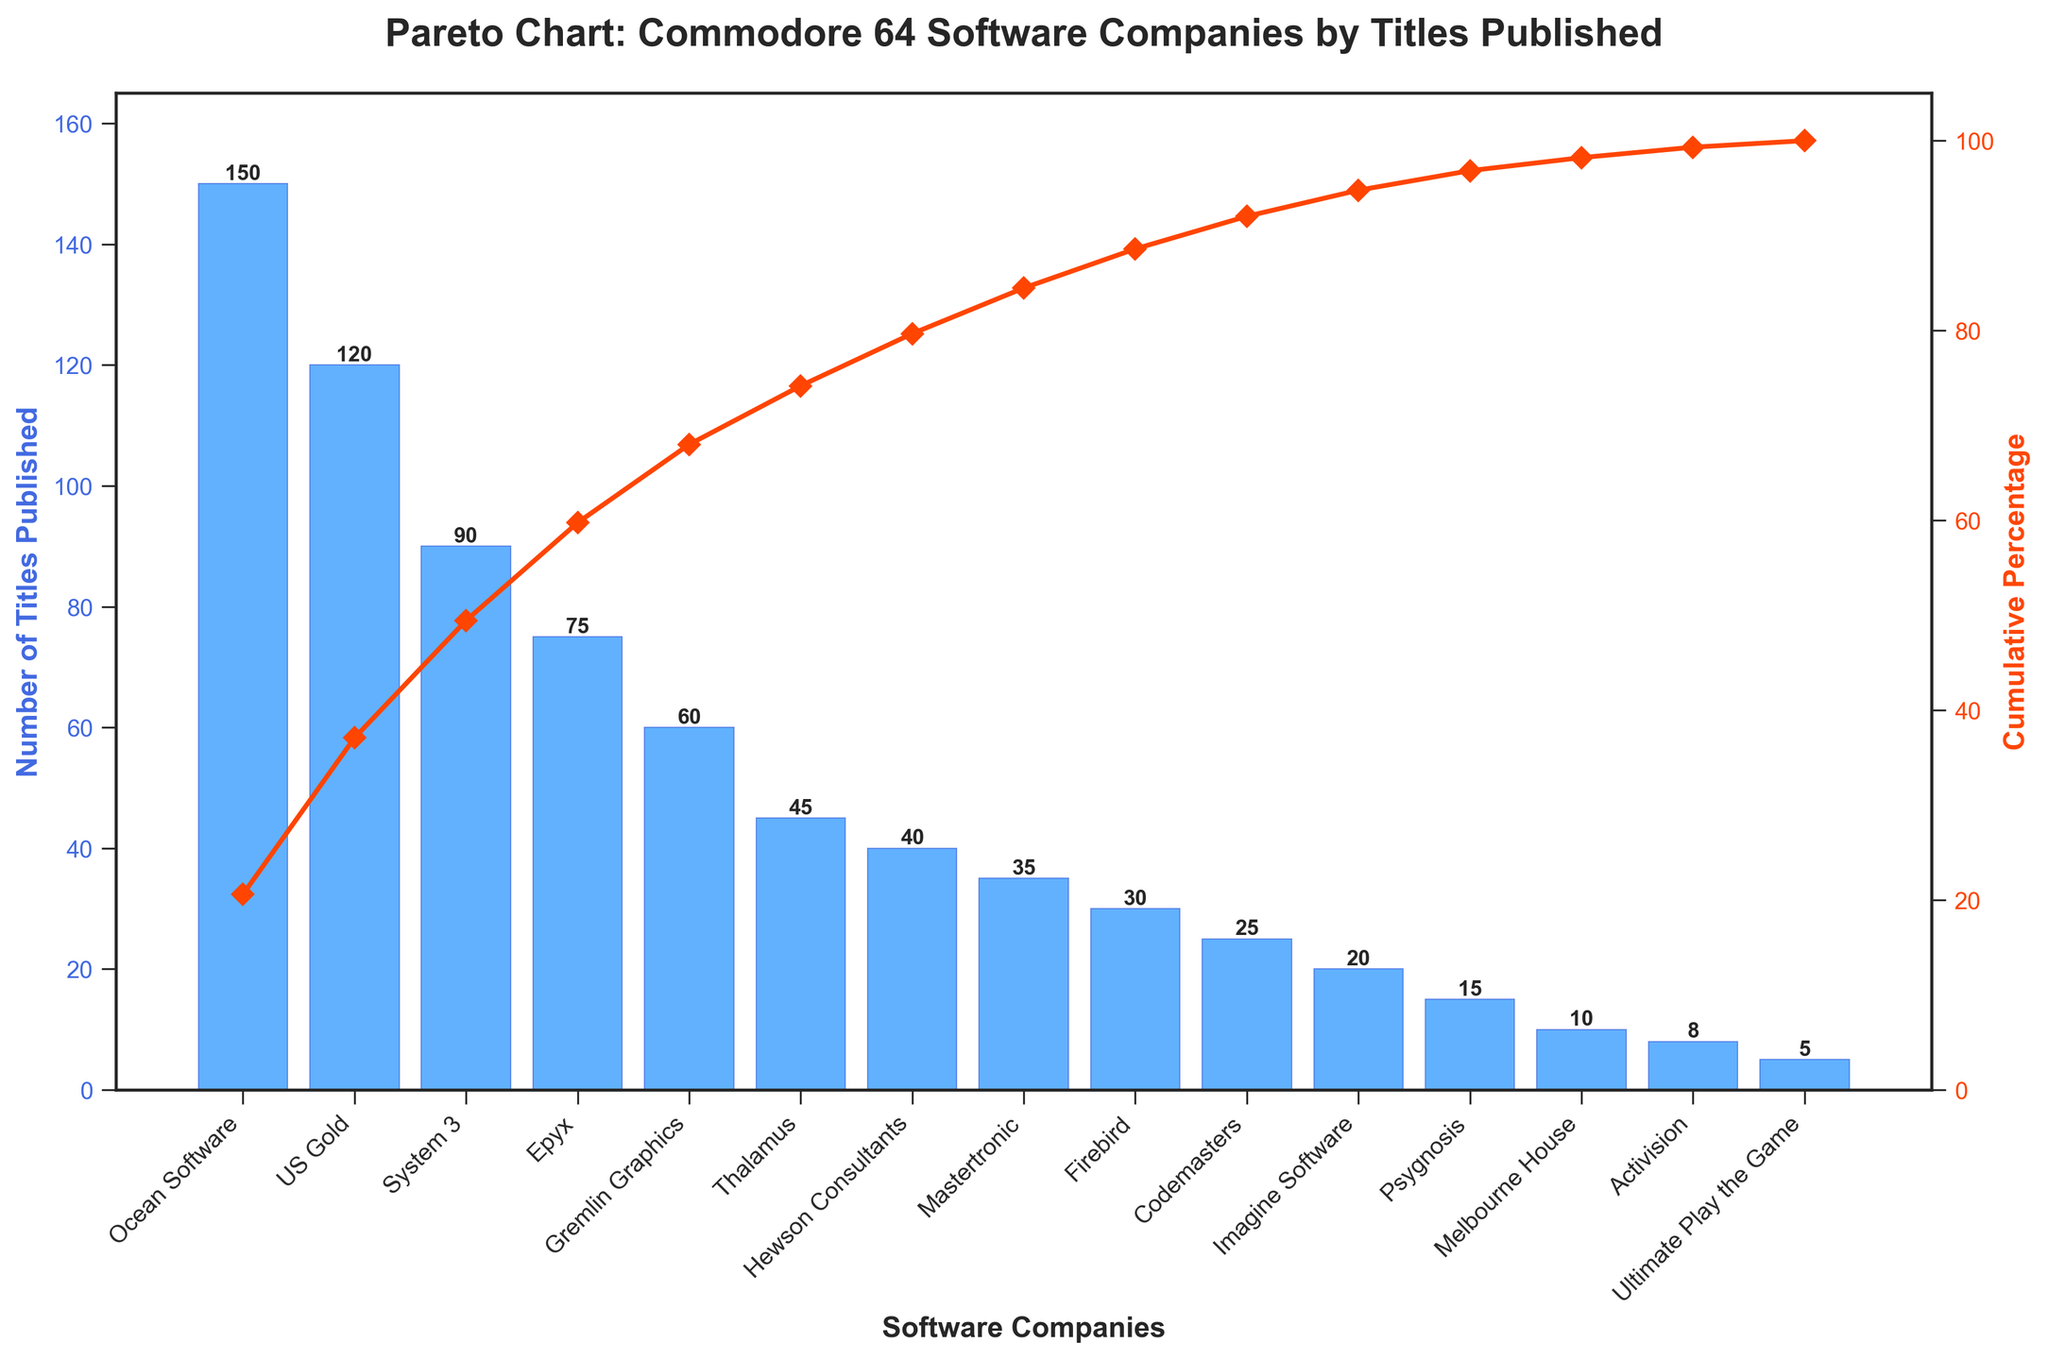what is the title of the figure? The title is displayed prominently at the top of the figure, indicating the main subject or information the figure represents.
Answer: Pareto Chart: Commodore 64 Software Companies by Titles Published how many companies published 30 or more titles? By evaluating the bars representing the number of titles, we count the companies that have a value of 30 or more. These include Ocean Software, US Gold, System 3, Epyx, Gremlin Graphics, Thalamus, Hewson Consultants, Mastertronic, and Firebird.
Answer: 9 which company published the most titles? Observing the lengths of the bars, the longest bar indicates the company with the most titles published. This bar corresponds to Ocean Software.
Answer: Ocean Software what's the approximate cumulative percentage for Gremlin Graphics? The corresponding position on the secondary y-axis for Gremlin Graphics should be noted from the plot. The cumulative percentage line intersects above the bar representing Gremlin Graphics. This point appears to be approximately 71%.
Answer: 71% how many titles were published by the top 3 companies combined? By summing the number of titles published by the top 3 companies: Ocean Software (150), US Gold (120), and System 3 (90): 150 + 120 + 90 = 360.
Answer: 360 how does Firebird compare to Codemasters in terms of the number of titles published? By comparing the heights of the bars for Firebird and Codemasters, it is evident that Firebird has a bar representing 30 titles, whereas Codemasters has a bar representing 25 titles. Firebird published more titles.
Answer: Firebird published more titles than Codemasters which two companies published the least number of titles? By looking at the shortest bars, the two companies with the least number of titles are Ultimate Play the Game and Activision, which have 5 and 8 titles published, respectively.
Answer: Ultimate Play the Game and Activision what percentage of the total titles published is accounted for by Ocean Software alone? Ocean Software published 150 titles. The total number of titles published by all companies is 758. The percentage is calculated as (150 / 758) * 100% = 19.8%.
Answer: 19.8% how many companies contribute to 80% of the total number of titles published? By following the cumulative percentage line on the secondary y-axis, the point where it reaches 80% should be noted. The companies contributing to this cumulative percentage include Ocean Software, US Gold, System 3, Epyx, Gremlin Graphics, and Thalamus, totaling 6 companies.
Answer: 6 what are the colors used in the figure for different elements, such as bars and the cumulative percentage line? The colors can be seen directly from the figure: bars are light blue, and the cumulative percentage line is bright red.
Answer: light blue for bars, bright red for cumulative percentage line 